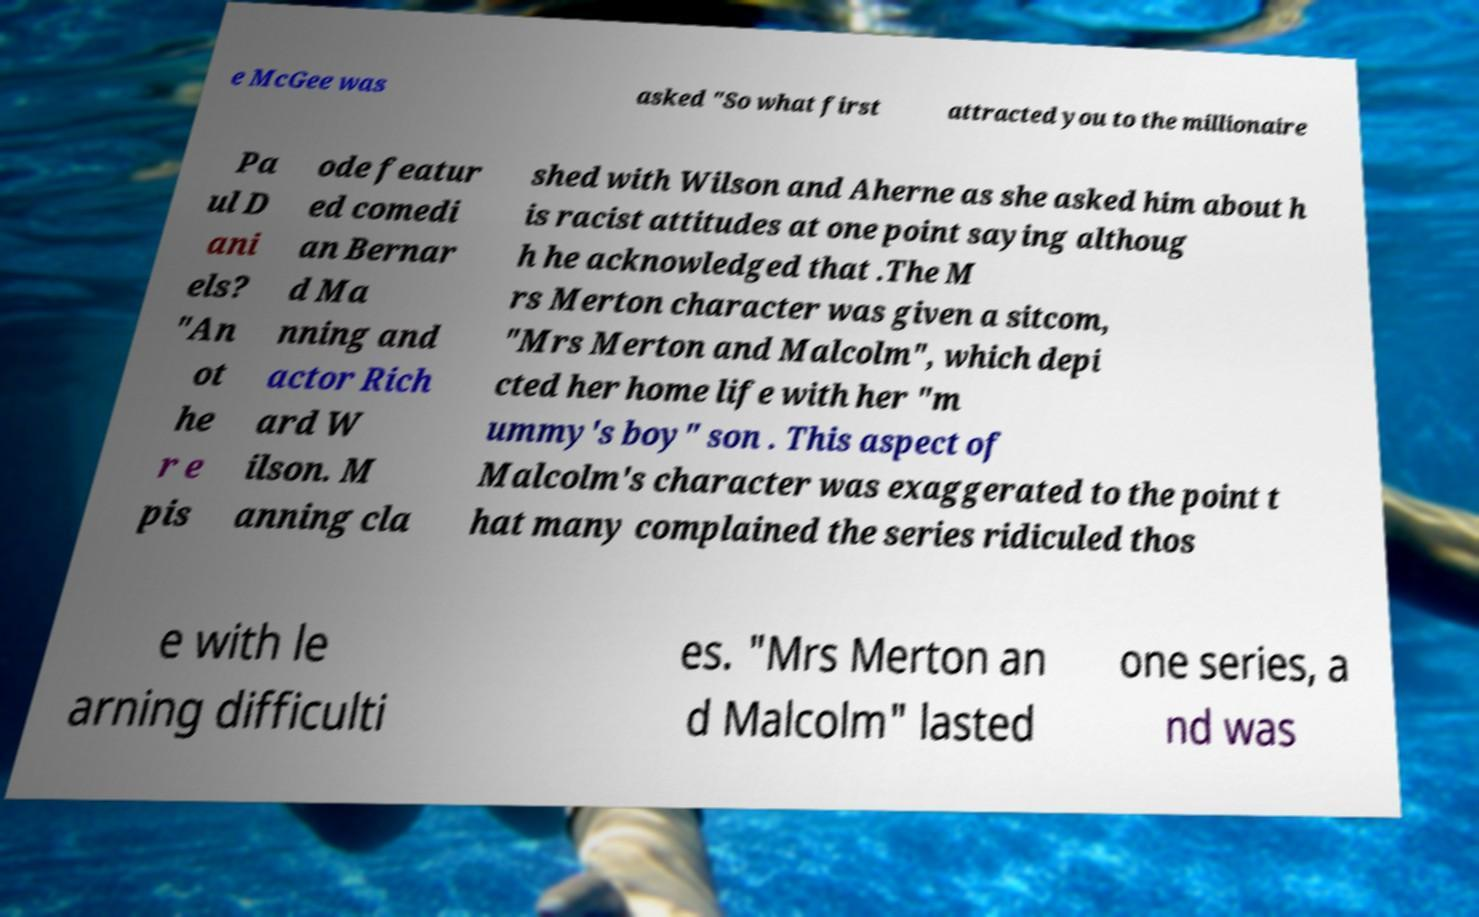Could you extract and type out the text from this image? e McGee was asked "So what first attracted you to the millionaire Pa ul D ani els? "An ot he r e pis ode featur ed comedi an Bernar d Ma nning and actor Rich ard W ilson. M anning cla shed with Wilson and Aherne as she asked him about h is racist attitudes at one point saying althoug h he acknowledged that .The M rs Merton character was given a sitcom, "Mrs Merton and Malcolm", which depi cted her home life with her "m ummy's boy" son . This aspect of Malcolm's character was exaggerated to the point t hat many complained the series ridiculed thos e with le arning difficulti es. "Mrs Merton an d Malcolm" lasted one series, a nd was 